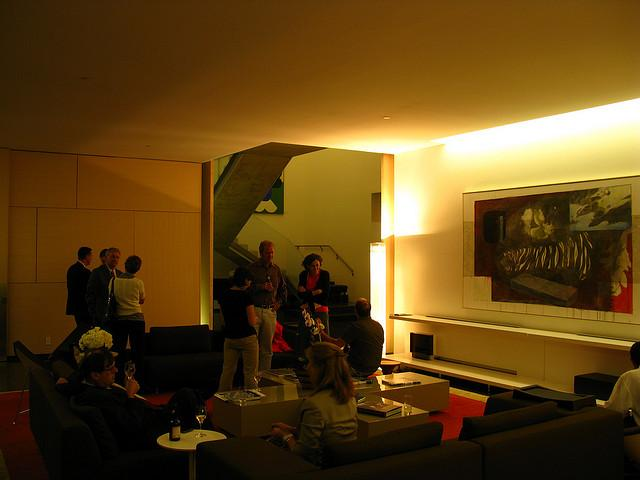What is the design of the staircase called? modern 